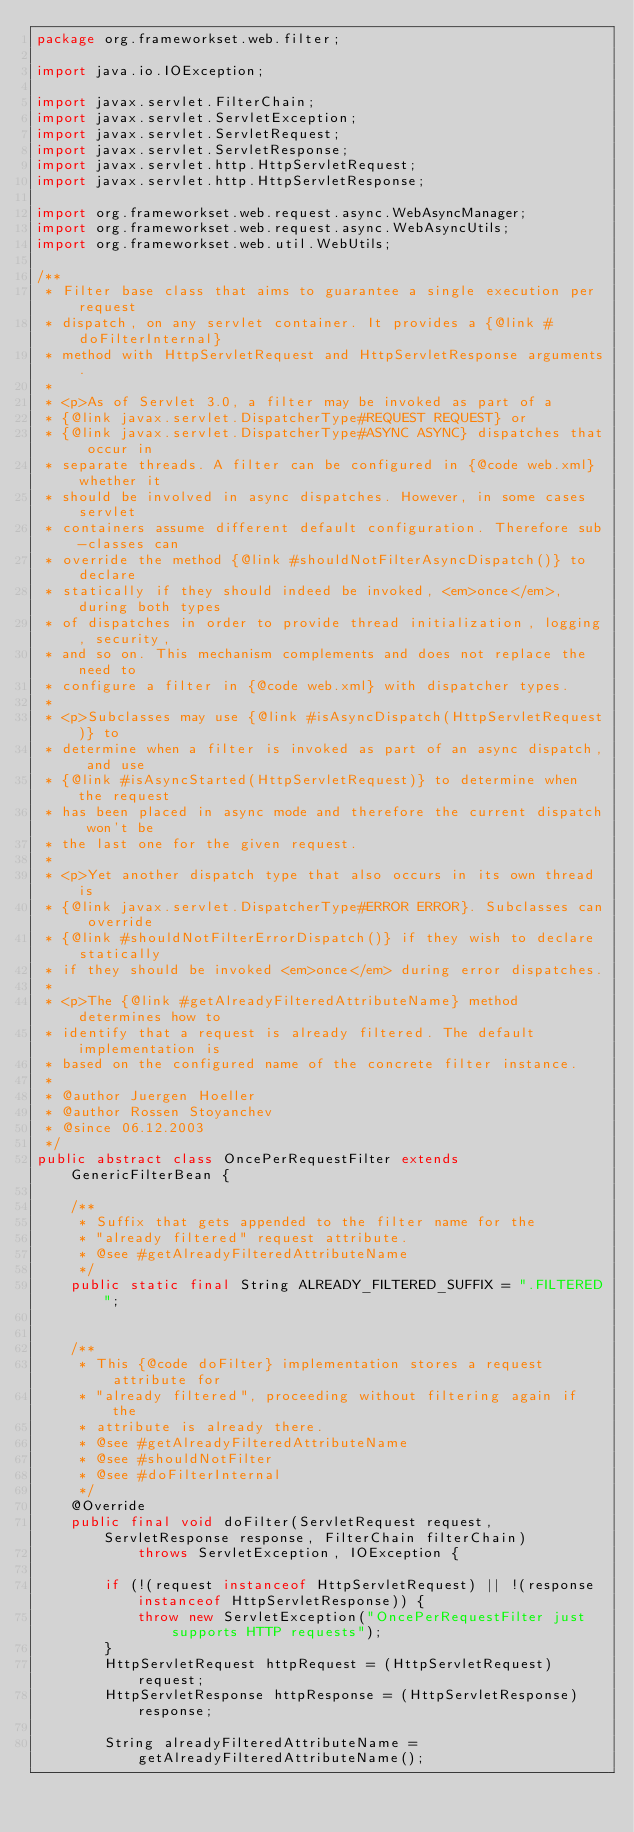<code> <loc_0><loc_0><loc_500><loc_500><_Java_>package org.frameworkset.web.filter;

import java.io.IOException;

import javax.servlet.FilterChain;
import javax.servlet.ServletException;
import javax.servlet.ServletRequest;
import javax.servlet.ServletResponse;
import javax.servlet.http.HttpServletRequest;
import javax.servlet.http.HttpServletResponse;

import org.frameworkset.web.request.async.WebAsyncManager;
import org.frameworkset.web.request.async.WebAsyncUtils;
import org.frameworkset.web.util.WebUtils;

/**
 * Filter base class that aims to guarantee a single execution per request
 * dispatch, on any servlet container. It provides a {@link #doFilterInternal}
 * method with HttpServletRequest and HttpServletResponse arguments.
 *
 * <p>As of Servlet 3.0, a filter may be invoked as part of a
 * {@link javax.servlet.DispatcherType#REQUEST REQUEST} or
 * {@link javax.servlet.DispatcherType#ASYNC ASYNC} dispatches that occur in
 * separate threads. A filter can be configured in {@code web.xml} whether it
 * should be involved in async dispatches. However, in some cases servlet
 * containers assume different default configuration. Therefore sub-classes can
 * override the method {@link #shouldNotFilterAsyncDispatch()} to declare
 * statically if they should indeed be invoked, <em>once</em>, during both types
 * of dispatches in order to provide thread initialization, logging, security,
 * and so on. This mechanism complements and does not replace the need to
 * configure a filter in {@code web.xml} with dispatcher types.
 *
 * <p>Subclasses may use {@link #isAsyncDispatch(HttpServletRequest)} to
 * determine when a filter is invoked as part of an async dispatch, and use
 * {@link #isAsyncStarted(HttpServletRequest)} to determine when the request
 * has been placed in async mode and therefore the current dispatch won't be
 * the last one for the given request.
 *
 * <p>Yet another dispatch type that also occurs in its own thread is
 * {@link javax.servlet.DispatcherType#ERROR ERROR}. Subclasses can override
 * {@link #shouldNotFilterErrorDispatch()} if they wish to declare statically
 * if they should be invoked <em>once</em> during error dispatches.
 *
 * <p>The {@link #getAlreadyFilteredAttributeName} method determines how to
 * identify that a request is already filtered. The default implementation is
 * based on the configured name of the concrete filter instance.
 *
 * @author Juergen Hoeller
 * @author Rossen Stoyanchev
 * @since 06.12.2003
 */
public abstract class OncePerRequestFilter extends GenericFilterBean {

	/**
	 * Suffix that gets appended to the filter name for the
	 * "already filtered" request attribute.
	 * @see #getAlreadyFilteredAttributeName
	 */
	public static final String ALREADY_FILTERED_SUFFIX = ".FILTERED";


	/**
	 * This {@code doFilter} implementation stores a request attribute for
	 * "already filtered", proceeding without filtering again if the
	 * attribute is already there.
	 * @see #getAlreadyFilteredAttributeName
	 * @see #shouldNotFilter
	 * @see #doFilterInternal
	 */
	@Override
	public final void doFilter(ServletRequest request, ServletResponse response, FilterChain filterChain)
			throws ServletException, IOException {

		if (!(request instanceof HttpServletRequest) || !(response instanceof HttpServletResponse)) {
			throw new ServletException("OncePerRequestFilter just supports HTTP requests");
		}
		HttpServletRequest httpRequest = (HttpServletRequest) request;
		HttpServletResponse httpResponse = (HttpServletResponse) response;

		String alreadyFilteredAttributeName = getAlreadyFilteredAttributeName();</code> 